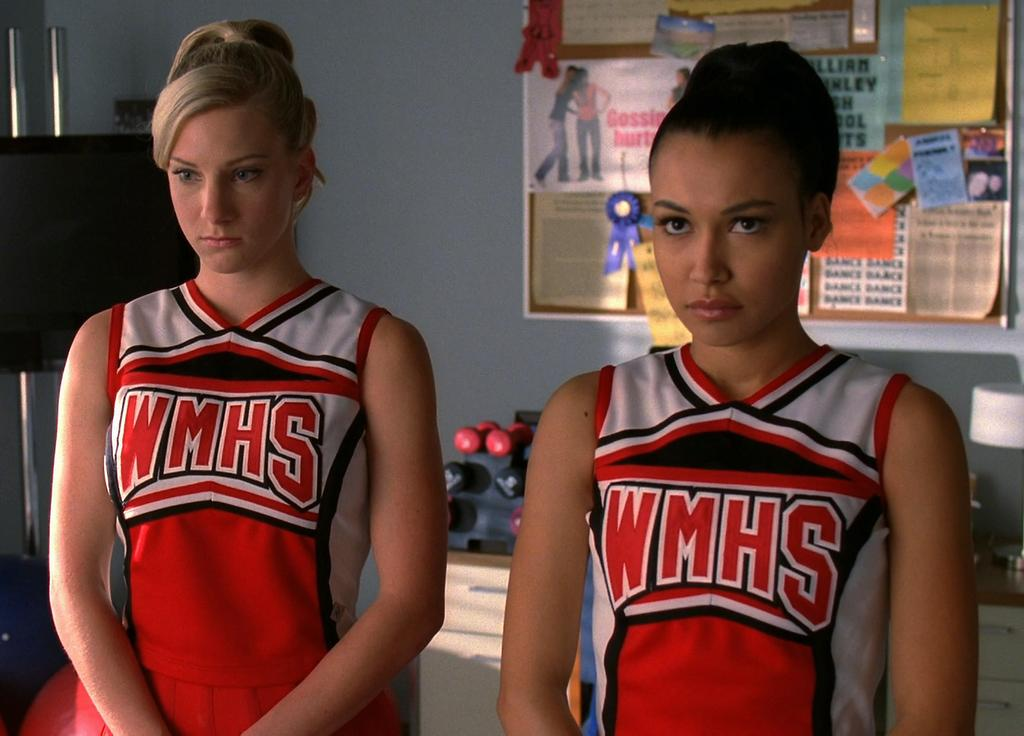<image>
Share a concise interpretation of the image provided. 2 women have cheerleading outfits that read WMHS. 